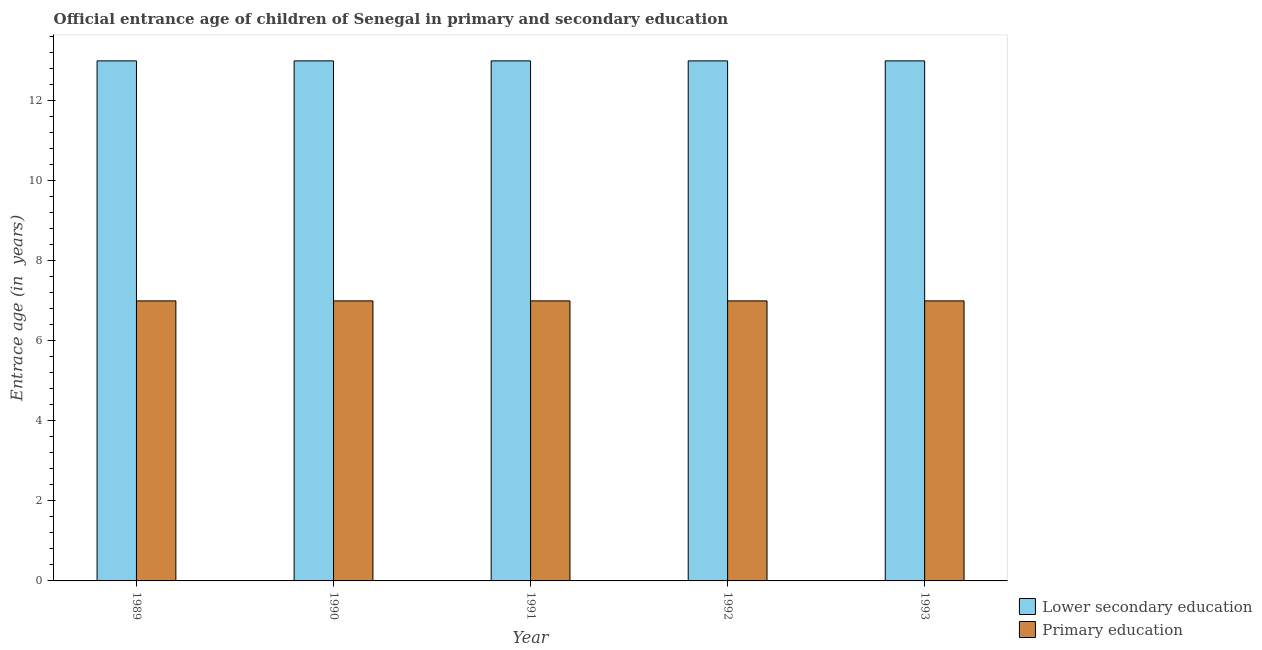Are the number of bars on each tick of the X-axis equal?
Offer a very short reply. Yes. How many bars are there on the 3rd tick from the right?
Offer a terse response. 2. What is the label of the 4th group of bars from the left?
Keep it short and to the point. 1992. In how many cases, is the number of bars for a given year not equal to the number of legend labels?
Your answer should be compact. 0. What is the entrance age of children in lower secondary education in 1993?
Ensure brevity in your answer.  13. Across all years, what is the maximum entrance age of chiildren in primary education?
Offer a very short reply. 7. Across all years, what is the minimum entrance age of chiildren in primary education?
Keep it short and to the point. 7. In which year was the entrance age of children in lower secondary education minimum?
Your answer should be compact. 1989. What is the total entrance age of children in lower secondary education in the graph?
Ensure brevity in your answer.  65. What is the difference between the entrance age of children in lower secondary education in 1989 and that in 1993?
Make the answer very short. 0. What is the difference between the entrance age of chiildren in primary education in 1989 and the entrance age of children in lower secondary education in 1991?
Keep it short and to the point. 0. What is the average entrance age of children in lower secondary education per year?
Offer a very short reply. 13. In the year 1991, what is the difference between the entrance age of children in lower secondary education and entrance age of chiildren in primary education?
Keep it short and to the point. 0. What is the ratio of the entrance age of children in lower secondary education in 1989 to that in 1993?
Your answer should be very brief. 1. Is the entrance age of children in lower secondary education in 1990 less than that in 1993?
Make the answer very short. No. Is the difference between the entrance age of chiildren in primary education in 1990 and 1991 greater than the difference between the entrance age of children in lower secondary education in 1990 and 1991?
Provide a short and direct response. No. In how many years, is the entrance age of chiildren in primary education greater than the average entrance age of chiildren in primary education taken over all years?
Keep it short and to the point. 0. Is the sum of the entrance age of children in lower secondary education in 1989 and 1991 greater than the maximum entrance age of chiildren in primary education across all years?
Ensure brevity in your answer.  Yes. What does the 2nd bar from the right in 1990 represents?
Offer a terse response. Lower secondary education. Are all the bars in the graph horizontal?
Ensure brevity in your answer.  No. How many years are there in the graph?
Make the answer very short. 5. Does the graph contain grids?
Offer a terse response. No. How many legend labels are there?
Your response must be concise. 2. What is the title of the graph?
Make the answer very short. Official entrance age of children of Senegal in primary and secondary education. Does "Register a business" appear as one of the legend labels in the graph?
Provide a succinct answer. No. What is the label or title of the X-axis?
Your response must be concise. Year. What is the label or title of the Y-axis?
Provide a succinct answer. Entrace age (in  years). What is the Entrace age (in  years) of Lower secondary education in 1989?
Give a very brief answer. 13. What is the Entrace age (in  years) of Lower secondary education in 1990?
Provide a succinct answer. 13. What is the Entrace age (in  years) of Primary education in 1990?
Your answer should be compact. 7. What is the Entrace age (in  years) of Lower secondary education in 1991?
Make the answer very short. 13. What is the Entrace age (in  years) of Primary education in 1991?
Make the answer very short. 7. What is the Entrace age (in  years) of Primary education in 1992?
Provide a short and direct response. 7. What is the Entrace age (in  years) of Primary education in 1993?
Provide a short and direct response. 7. Across all years, what is the maximum Entrace age (in  years) in Primary education?
Provide a succinct answer. 7. Across all years, what is the minimum Entrace age (in  years) in Lower secondary education?
Ensure brevity in your answer.  13. Across all years, what is the minimum Entrace age (in  years) of Primary education?
Give a very brief answer. 7. What is the total Entrace age (in  years) in Primary education in the graph?
Provide a succinct answer. 35. What is the difference between the Entrace age (in  years) in Lower secondary education in 1989 and that in 1990?
Your response must be concise. 0. What is the difference between the Entrace age (in  years) in Primary education in 1989 and that in 1990?
Offer a very short reply. 0. What is the difference between the Entrace age (in  years) in Primary education in 1989 and that in 1992?
Give a very brief answer. 0. What is the difference between the Entrace age (in  years) of Lower secondary education in 1989 and that in 1993?
Give a very brief answer. 0. What is the difference between the Entrace age (in  years) of Lower secondary education in 1990 and that in 1991?
Your response must be concise. 0. What is the difference between the Entrace age (in  years) of Primary education in 1990 and that in 1992?
Make the answer very short. 0. What is the difference between the Entrace age (in  years) of Lower secondary education in 1990 and that in 1993?
Make the answer very short. 0. What is the difference between the Entrace age (in  years) of Primary education in 1990 and that in 1993?
Your answer should be very brief. 0. What is the difference between the Entrace age (in  years) in Lower secondary education in 1991 and that in 1992?
Keep it short and to the point. 0. What is the difference between the Entrace age (in  years) of Primary education in 1991 and that in 1992?
Make the answer very short. 0. What is the difference between the Entrace age (in  years) of Lower secondary education in 1989 and the Entrace age (in  years) of Primary education in 1991?
Make the answer very short. 6. What is the difference between the Entrace age (in  years) of Lower secondary education in 1990 and the Entrace age (in  years) of Primary education in 1992?
Provide a succinct answer. 6. What is the difference between the Entrace age (in  years) of Lower secondary education in 1990 and the Entrace age (in  years) of Primary education in 1993?
Give a very brief answer. 6. What is the difference between the Entrace age (in  years) in Lower secondary education in 1991 and the Entrace age (in  years) in Primary education in 1992?
Your answer should be compact. 6. What is the difference between the Entrace age (in  years) in Lower secondary education in 1991 and the Entrace age (in  years) in Primary education in 1993?
Ensure brevity in your answer.  6. What is the difference between the Entrace age (in  years) in Lower secondary education in 1992 and the Entrace age (in  years) in Primary education in 1993?
Provide a short and direct response. 6. What is the average Entrace age (in  years) of Lower secondary education per year?
Provide a short and direct response. 13. In the year 1989, what is the difference between the Entrace age (in  years) of Lower secondary education and Entrace age (in  years) of Primary education?
Offer a very short reply. 6. In the year 1993, what is the difference between the Entrace age (in  years) of Lower secondary education and Entrace age (in  years) of Primary education?
Ensure brevity in your answer.  6. What is the ratio of the Entrace age (in  years) in Lower secondary education in 1989 to that in 1990?
Make the answer very short. 1. What is the ratio of the Entrace age (in  years) in Primary education in 1989 to that in 1990?
Provide a succinct answer. 1. What is the ratio of the Entrace age (in  years) in Lower secondary education in 1989 to that in 1992?
Ensure brevity in your answer.  1. What is the ratio of the Entrace age (in  years) of Primary education in 1990 to that in 1992?
Give a very brief answer. 1. What is the ratio of the Entrace age (in  years) in Lower secondary education in 1990 to that in 1993?
Provide a succinct answer. 1. What is the ratio of the Entrace age (in  years) of Primary education in 1990 to that in 1993?
Keep it short and to the point. 1. What is the ratio of the Entrace age (in  years) in Lower secondary education in 1991 to that in 1992?
Give a very brief answer. 1. What is the ratio of the Entrace age (in  years) of Primary education in 1991 to that in 1992?
Ensure brevity in your answer.  1. What is the ratio of the Entrace age (in  years) in Lower secondary education in 1991 to that in 1993?
Make the answer very short. 1. What is the ratio of the Entrace age (in  years) in Lower secondary education in 1992 to that in 1993?
Offer a very short reply. 1. What is the difference between the highest and the second highest Entrace age (in  years) of Primary education?
Your response must be concise. 0. What is the difference between the highest and the lowest Entrace age (in  years) in Lower secondary education?
Keep it short and to the point. 0. What is the difference between the highest and the lowest Entrace age (in  years) of Primary education?
Your answer should be compact. 0. 